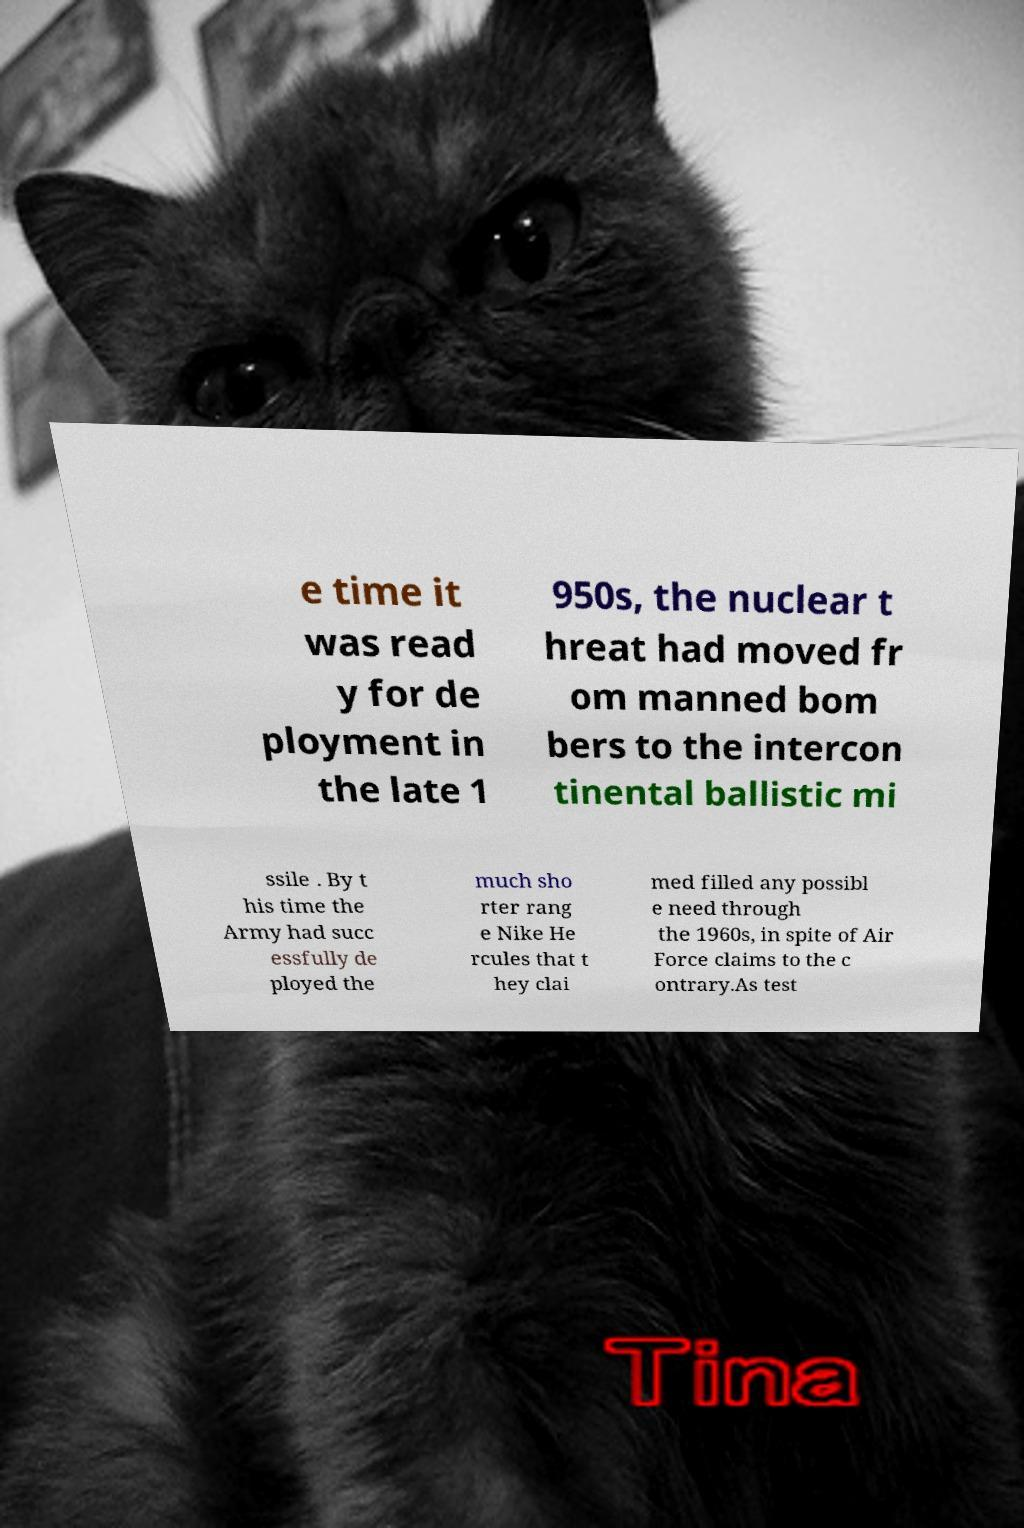There's text embedded in this image that I need extracted. Can you transcribe it verbatim? e time it was read y for de ployment in the late 1 950s, the nuclear t hreat had moved fr om manned bom bers to the intercon tinental ballistic mi ssile . By t his time the Army had succ essfully de ployed the much sho rter rang e Nike He rcules that t hey clai med filled any possibl e need through the 1960s, in spite of Air Force claims to the c ontrary.As test 